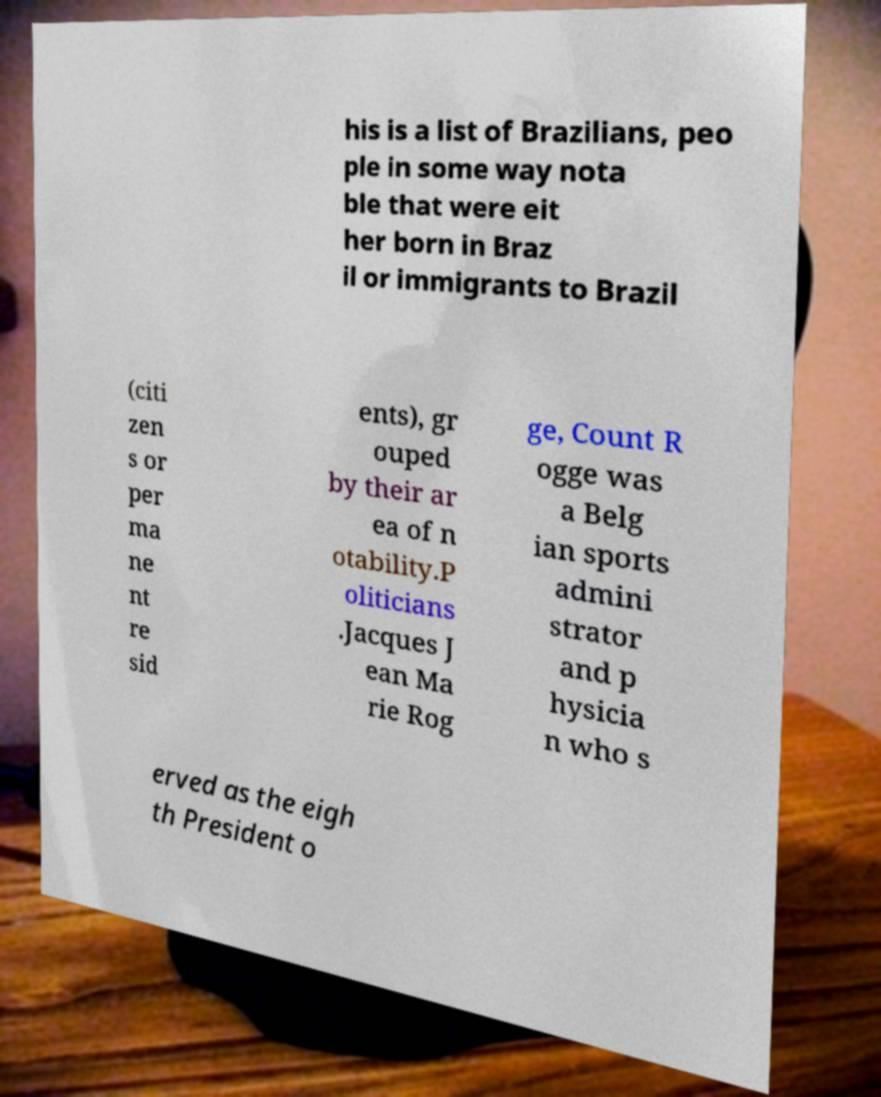Please read and relay the text visible in this image. What does it say? his is a list of Brazilians, peo ple in some way nota ble that were eit her born in Braz il or immigrants to Brazil (citi zen s or per ma ne nt re sid ents), gr ouped by their ar ea of n otability.P oliticians .Jacques J ean Ma rie Rog ge, Count R ogge was a Belg ian sports admini strator and p hysicia n who s erved as the eigh th President o 